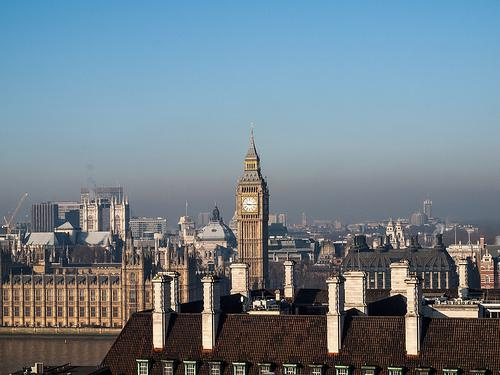Question: what is brown?
Choices:
A. Roof tops.
B. Sidewalk.
C. Wall.
D. Car park.
Answer with the letter. Answer: A Question: how many clocks?
Choices:
A. 0.
B. 1.
C. 4.
D. 2.
Answer with the letter. Answer: B Question: when was the picture taken?
Choices:
A. Evening.
B. Daytime.
C. Midnight.
D. Dawn.
Answer with the letter. Answer: B Question: what is brown?
Choices:
A. Pole.
B. Staff.
C. Tower.
D. Club.
Answer with the letter. Answer: C 